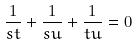Convert formula to latex. <formula><loc_0><loc_0><loc_500><loc_500>\frac { 1 } { s t } + \frac { 1 } { s u } + \frac { 1 } { t u } = 0</formula> 